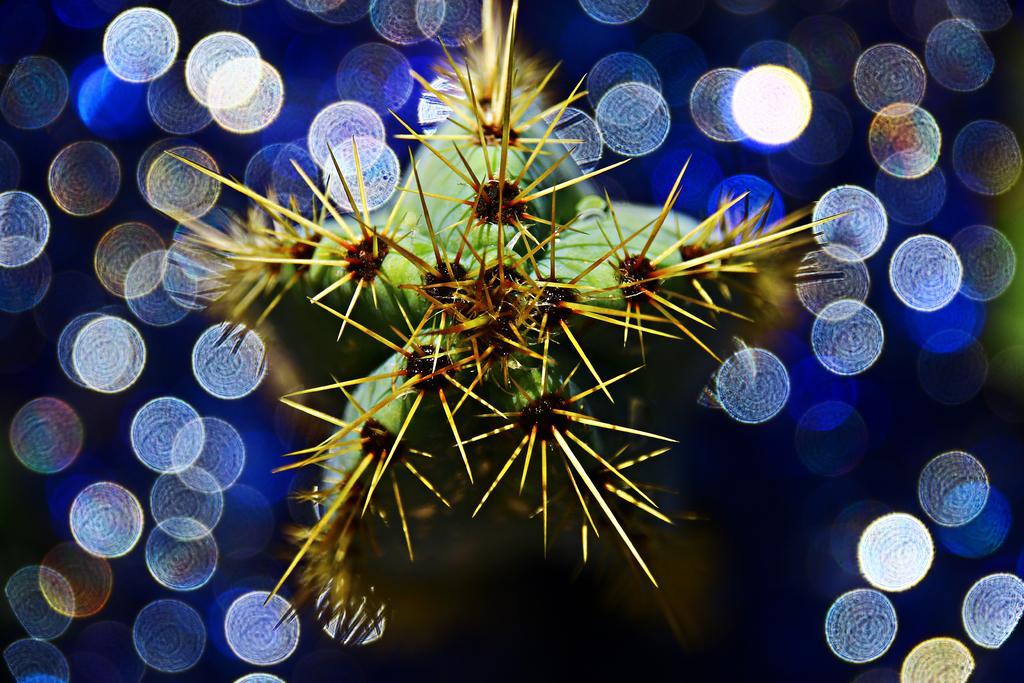Please provide a concise description of this image. This is an edited picture and in the middle, it seems like a plant and around it, there are light focus. 